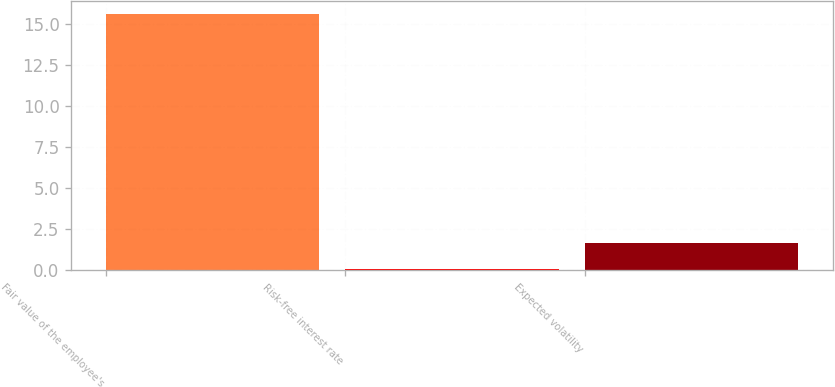<chart> <loc_0><loc_0><loc_500><loc_500><bar_chart><fcel>Fair value of the employee's<fcel>Risk-free interest rate<fcel>Expected volatility<nl><fcel>15.58<fcel>0.1<fcel>1.65<nl></chart> 